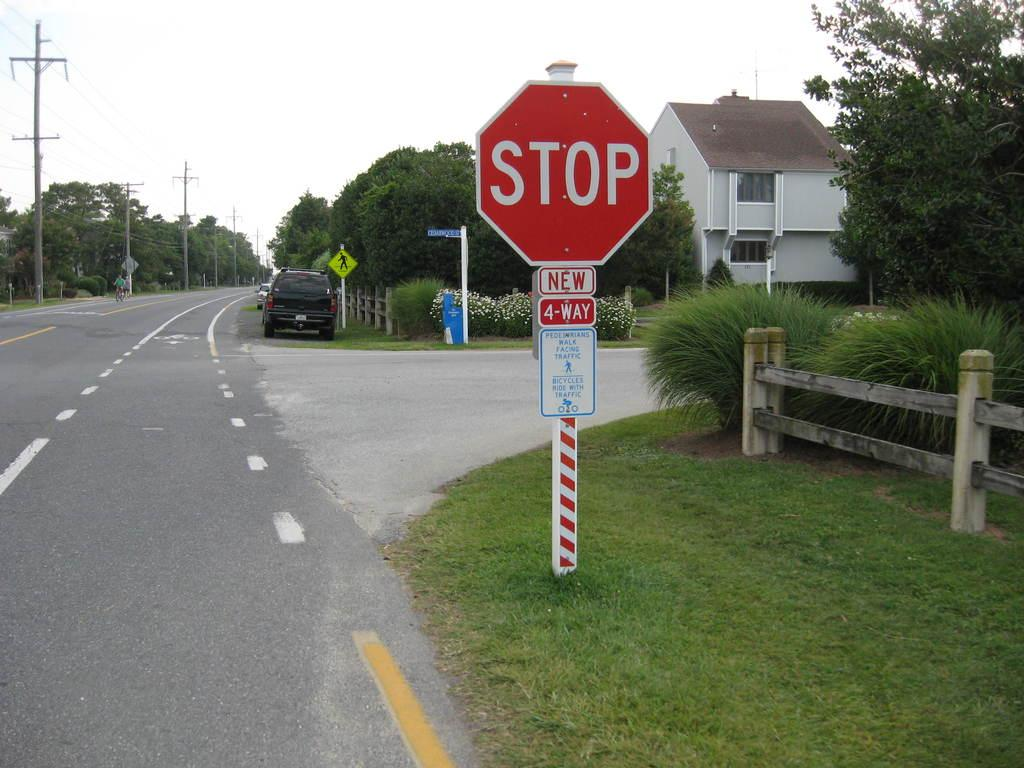<image>
Give a short and clear explanation of the subsequent image. The sign under the stop sign states that pedestrians must walk facing the traffic. 